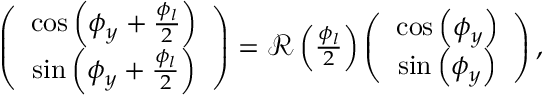<formula> <loc_0><loc_0><loc_500><loc_500>\begin{array} { r } { \left ( \begin{array} { c } { \cos \left ( \phi _ { y } + \frac { \phi _ { l } } { 2 } \right ) } \\ { \sin \left ( \phi _ { y } + \frac { \phi _ { l } } { 2 } \right ) } \end{array} \right ) = { \mathcal { R } } \left ( \frac { \phi _ { l } } { 2 } \right ) \left ( \begin{array} { c } { \cos \left ( \phi _ { y } \right ) } \\ { \sin \left ( \phi _ { y } \right ) } \end{array} \right ) , } \end{array}</formula> 